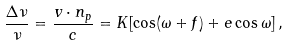Convert formula to latex. <formula><loc_0><loc_0><loc_500><loc_500>\frac { \Delta \nu } { \nu } = \frac { { v } \cdot { n } _ { p } } { c } = K [ \cos ( \omega + f ) + e \cos \omega ] \, ,</formula> 